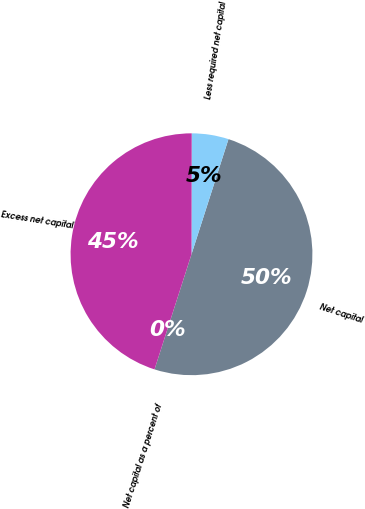Convert chart to OTSL. <chart><loc_0><loc_0><loc_500><loc_500><pie_chart><fcel>Net capital as a percent of<fcel>Net capital<fcel>Less required net capital<fcel>Excess net capital<nl><fcel>0.0%<fcel>50.0%<fcel>4.92%<fcel>45.08%<nl></chart> 